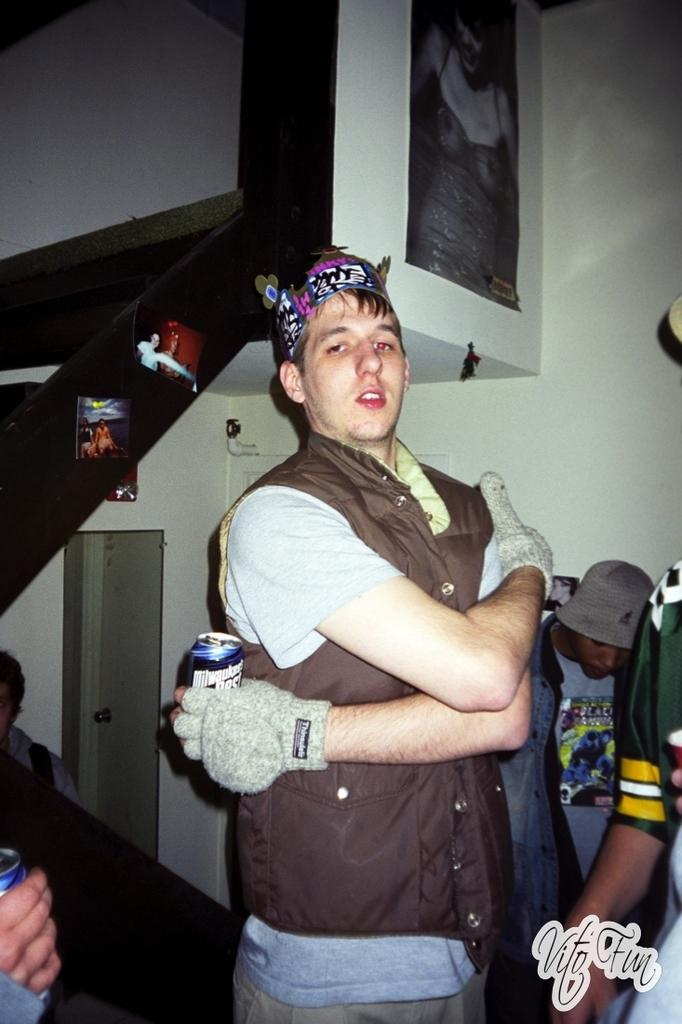Who or what can be seen in the image? There are people in the image. What is visible in the background of the image? There is a wall and objects in the background of the image. Can you describe the text in the bottom right of the image? The text in the bottom right of the image is not legible from the provided facts. What type of lock is used to secure the unit in the image? There is no lock or unit present in the image. How does the pump function in the image? There is no pump present in the image. 